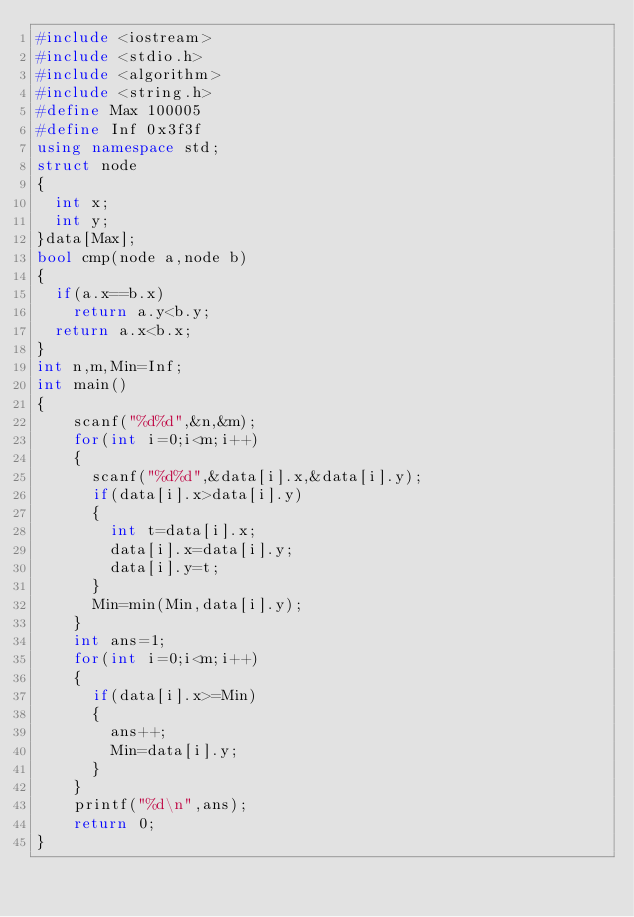Convert code to text. <code><loc_0><loc_0><loc_500><loc_500><_C++_>#include <iostream>
#include <stdio.h>
#include <algorithm>
#include <string.h>
#define Max 100005
#define Inf 0x3f3f
using namespace std;
struct node
{
	int x;
	int y;
}data[Max];
bool cmp(node a,node b)
{
	if(a.x==b.x)
		return a.y<b.y;
	return a.x<b.x;
}
int n,m,Min=Inf;
int main()
{
		scanf("%d%d",&n,&m);
		for(int i=0;i<m;i++)
		{
			scanf("%d%d",&data[i].x,&data[i].y);
			if(data[i].x>data[i].y)
			{
				int t=data[i].x;
				data[i].x=data[i].y;
				data[i].y=t;
			}
			Min=min(Min,data[i].y);
		}
		int ans=1;
		for(int i=0;i<m;i++)
		{
			if(data[i].x>=Min)
			{
				ans++;
				Min=data[i].y;
			}
		}
		printf("%d\n",ans);
    return 0;
}
</code> 